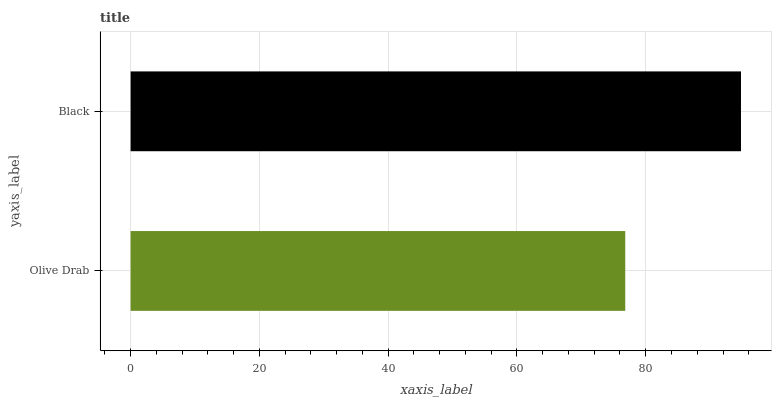Is Olive Drab the minimum?
Answer yes or no. Yes. Is Black the maximum?
Answer yes or no. Yes. Is Black the minimum?
Answer yes or no. No. Is Black greater than Olive Drab?
Answer yes or no. Yes. Is Olive Drab less than Black?
Answer yes or no. Yes. Is Olive Drab greater than Black?
Answer yes or no. No. Is Black less than Olive Drab?
Answer yes or no. No. Is Black the high median?
Answer yes or no. Yes. Is Olive Drab the low median?
Answer yes or no. Yes. Is Olive Drab the high median?
Answer yes or no. No. Is Black the low median?
Answer yes or no. No. 